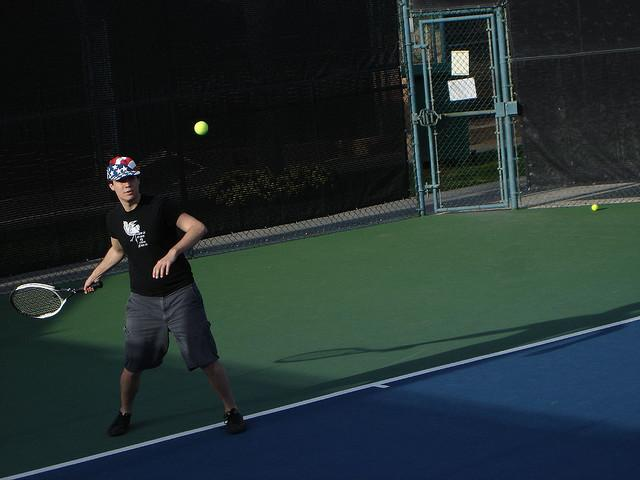Why is their hand held way back?

Choices:
A) stop falling
B) swat mosquito
C) swing ball
D) self defense swing ball 